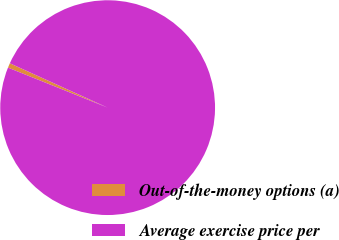Convert chart. <chart><loc_0><loc_0><loc_500><loc_500><pie_chart><fcel>Out-of-the-money options (a)<fcel>Average exercise price per<nl><fcel>0.7%<fcel>99.3%<nl></chart> 